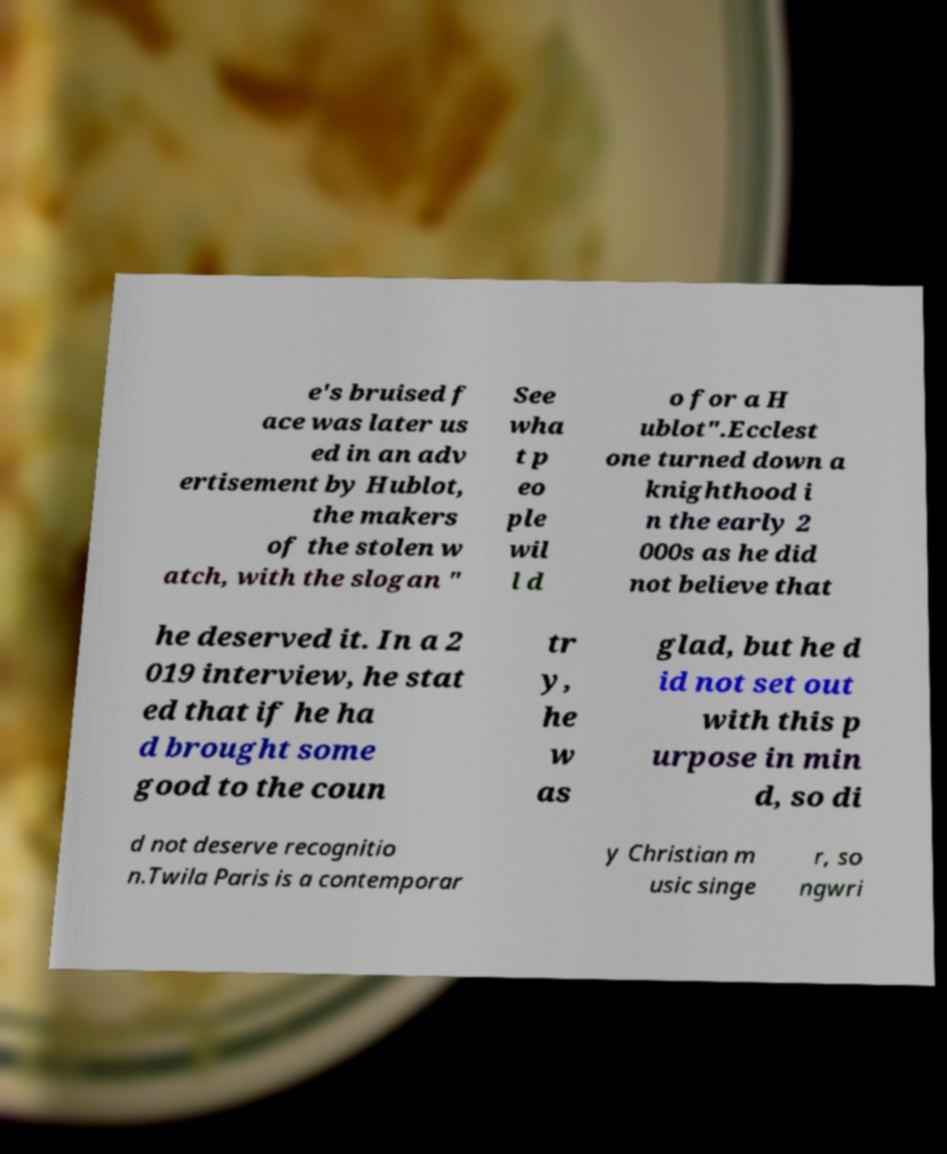Could you assist in decoding the text presented in this image and type it out clearly? e's bruised f ace was later us ed in an adv ertisement by Hublot, the makers of the stolen w atch, with the slogan " See wha t p eo ple wil l d o for a H ublot".Ecclest one turned down a knighthood i n the early 2 000s as he did not believe that he deserved it. In a 2 019 interview, he stat ed that if he ha d brought some good to the coun tr y, he w as glad, but he d id not set out with this p urpose in min d, so di d not deserve recognitio n.Twila Paris is a contemporar y Christian m usic singe r, so ngwri 